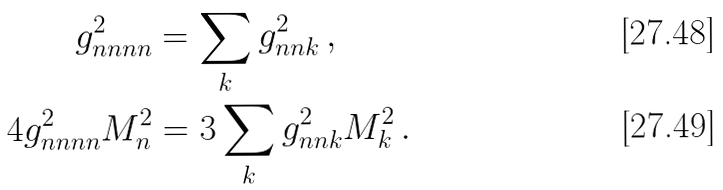Convert formula to latex. <formula><loc_0><loc_0><loc_500><loc_500>g ^ { 2 } _ { n n n n } & = \sum _ { k } g ^ { 2 } _ { n n k } \, , \\ 4 g ^ { 2 } _ { n n n n } M _ { n } ^ { 2 } & = 3 \sum _ { k } g ^ { 2 } _ { n n k } M ^ { 2 } _ { k } \, .</formula> 